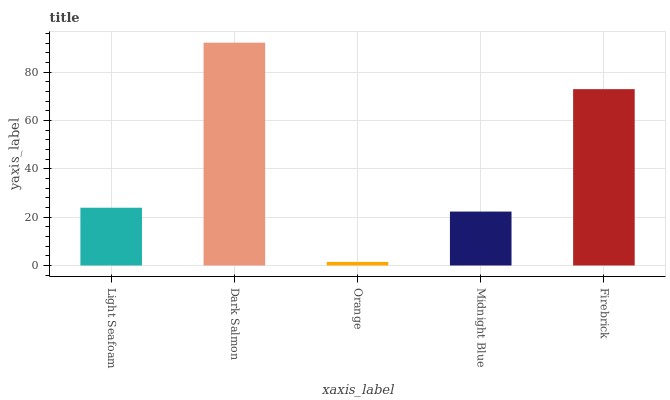Is Orange the minimum?
Answer yes or no. Yes. Is Dark Salmon the maximum?
Answer yes or no. Yes. Is Dark Salmon the minimum?
Answer yes or no. No. Is Orange the maximum?
Answer yes or no. No. Is Dark Salmon greater than Orange?
Answer yes or no. Yes. Is Orange less than Dark Salmon?
Answer yes or no. Yes. Is Orange greater than Dark Salmon?
Answer yes or no. No. Is Dark Salmon less than Orange?
Answer yes or no. No. Is Light Seafoam the high median?
Answer yes or no. Yes. Is Light Seafoam the low median?
Answer yes or no. Yes. Is Orange the high median?
Answer yes or no. No. Is Midnight Blue the low median?
Answer yes or no. No. 